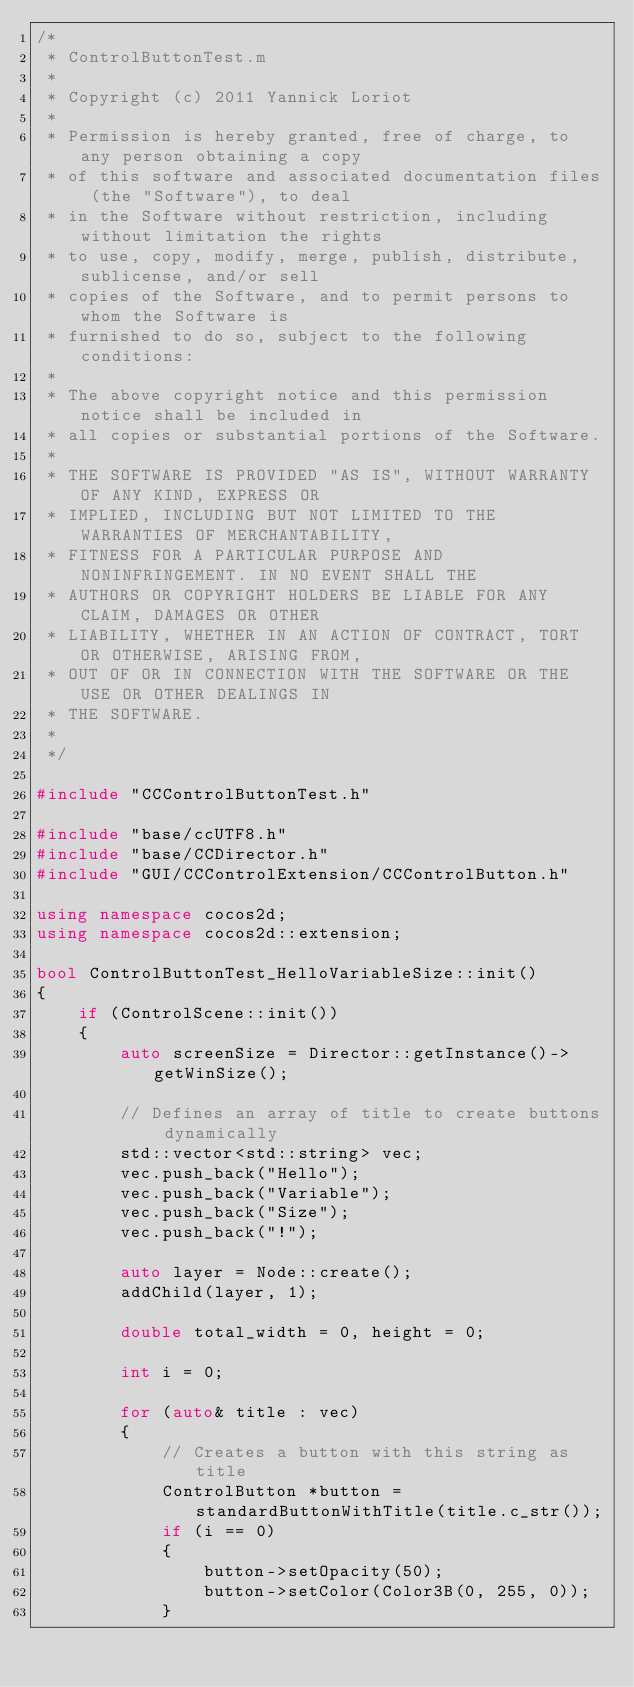<code> <loc_0><loc_0><loc_500><loc_500><_C++_>/*
 * ControlButtonTest.m
 *
 * Copyright (c) 2011 Yannick Loriot
 *
 * Permission is hereby granted, free of charge, to any person obtaining a copy
 * of this software and associated documentation files (the "Software"), to deal
 * in the Software without restriction, including without limitation the rights
 * to use, copy, modify, merge, publish, distribute, sublicense, and/or sell
 * copies of the Software, and to permit persons to whom the Software is
 * furnished to do so, subject to the following conditions:
 *
 * The above copyright notice and this permission notice shall be included in
 * all copies or substantial portions of the Software.
 *
 * THE SOFTWARE IS PROVIDED "AS IS", WITHOUT WARRANTY OF ANY KIND, EXPRESS OR
 * IMPLIED, INCLUDING BUT NOT LIMITED TO THE WARRANTIES OF MERCHANTABILITY,
 * FITNESS FOR A PARTICULAR PURPOSE AND NONINFRINGEMENT. IN NO EVENT SHALL THE
 * AUTHORS OR COPYRIGHT HOLDERS BE LIABLE FOR ANY CLAIM, DAMAGES OR OTHER
 * LIABILITY, WHETHER IN AN ACTION OF CONTRACT, TORT OR OTHERWISE, ARISING FROM,
 * OUT OF OR IN CONNECTION WITH THE SOFTWARE OR THE USE OR OTHER DEALINGS IN
 * THE SOFTWARE.
 *
 */

#include "CCControlButtonTest.h"

#include "base/ccUTF8.h"
#include "base/CCDirector.h"
#include "GUI/CCControlExtension/CCControlButton.h"

using namespace cocos2d;
using namespace cocos2d::extension;

bool ControlButtonTest_HelloVariableSize::init()
{
    if (ControlScene::init())
    {
        auto screenSize = Director::getInstance()->getWinSize();
        
        // Defines an array of title to create buttons dynamically
        std::vector<std::string> vec;
        vec.push_back("Hello");
        vec.push_back("Variable");
        vec.push_back("Size");
        vec.push_back("!");
        
        auto layer = Node::create();
        addChild(layer, 1);
        
        double total_width = 0, height = 0;
        
        int i = 0;
        
        for (auto& title : vec)
        {
            // Creates a button with this string as title
            ControlButton *button = standardButtonWithTitle(title.c_str());
            if (i == 0)
            {
                button->setOpacity(50);
                button->setColor(Color3B(0, 255, 0));
            }</code> 